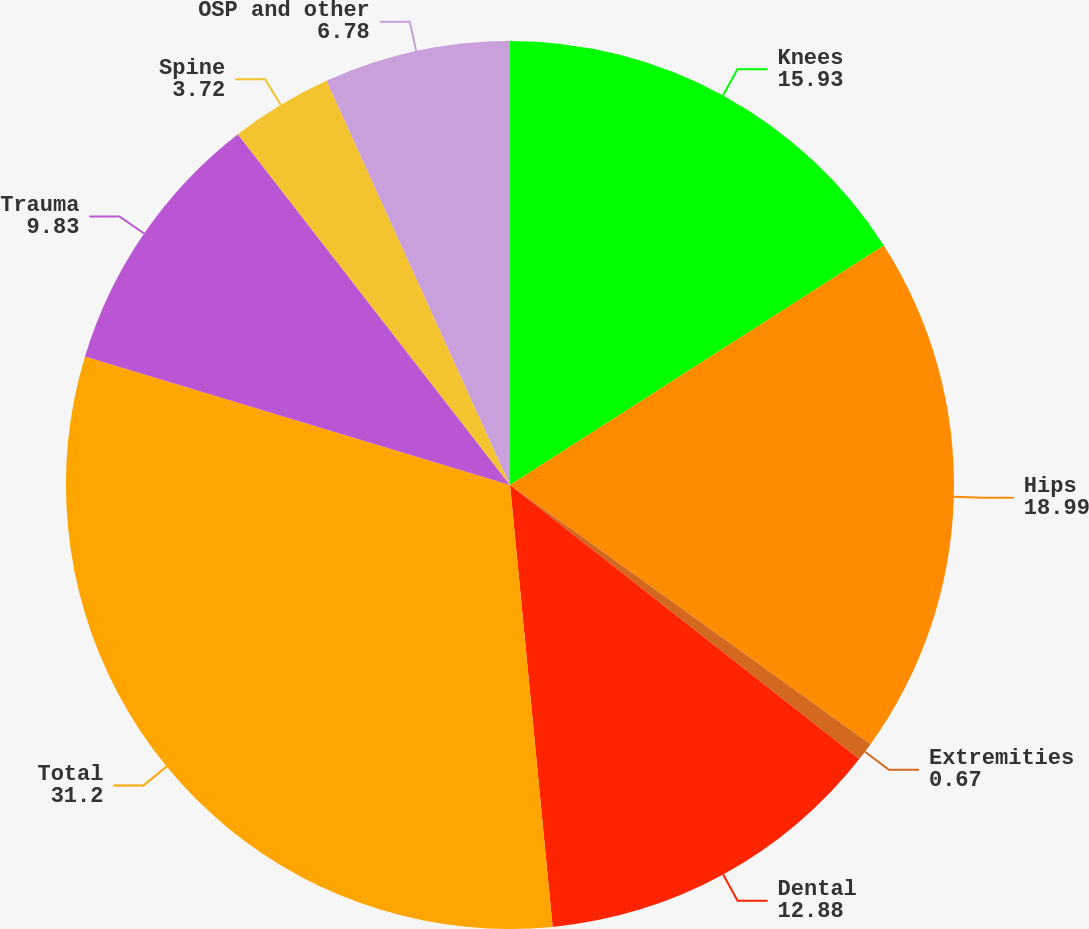Convert chart. <chart><loc_0><loc_0><loc_500><loc_500><pie_chart><fcel>Knees<fcel>Hips<fcel>Extremities<fcel>Dental<fcel>Total<fcel>Trauma<fcel>Spine<fcel>OSP and other<nl><fcel>15.93%<fcel>18.99%<fcel>0.67%<fcel>12.88%<fcel>31.2%<fcel>9.83%<fcel>3.72%<fcel>6.78%<nl></chart> 